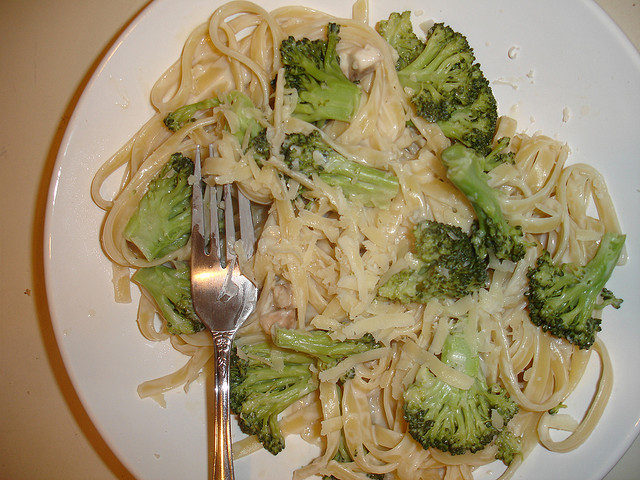<image>What sauce is on this pasta? I don't know what sauce is on the pasta. It could be alfredo, tomato sauce, or butter. What sauce is on this pasta? I am not sure what sauce is on this pasta. It can be seen 'tomato sauce', 'alfredo', 'butter' or 'antipasto'. 